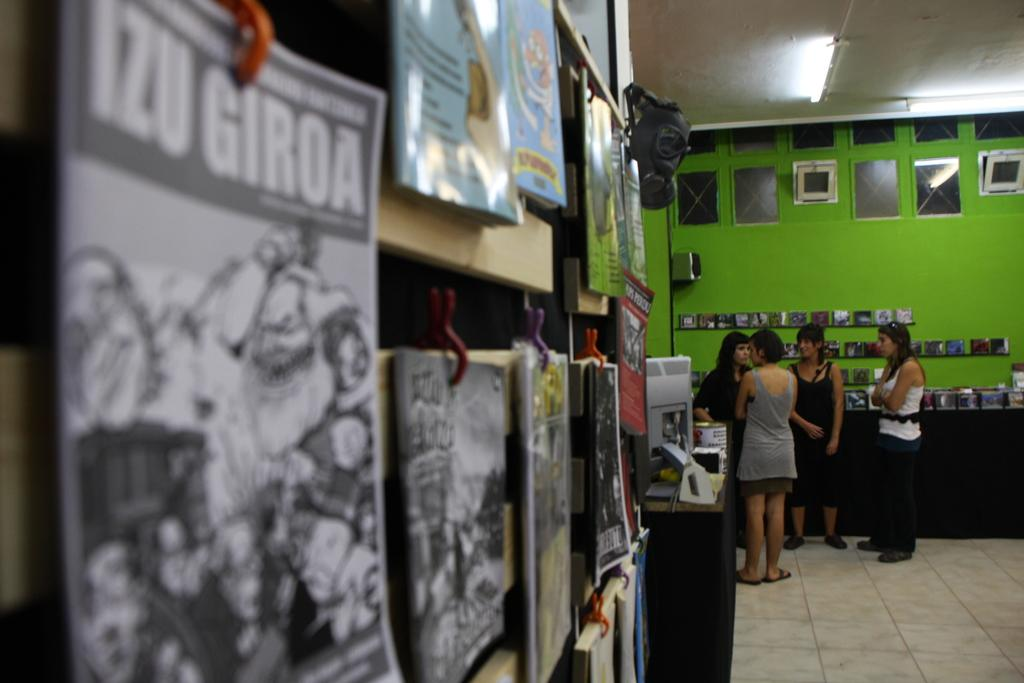What type of items can be seen in the image? There are books, frames, lights, tables, and objects in the image. Are there any people present in the image? Yes, there are people in the image. What can be seen on the floor in the image? The floor is visible in the image. What is visible on the wall in the image? The wall is visible in the image. How many frogs are sitting on the books in the image? There are no frogs present in the image. What type of health advice can be found in the frames in the image? There is no health advice present in the image, as the frames contain other types of content. 